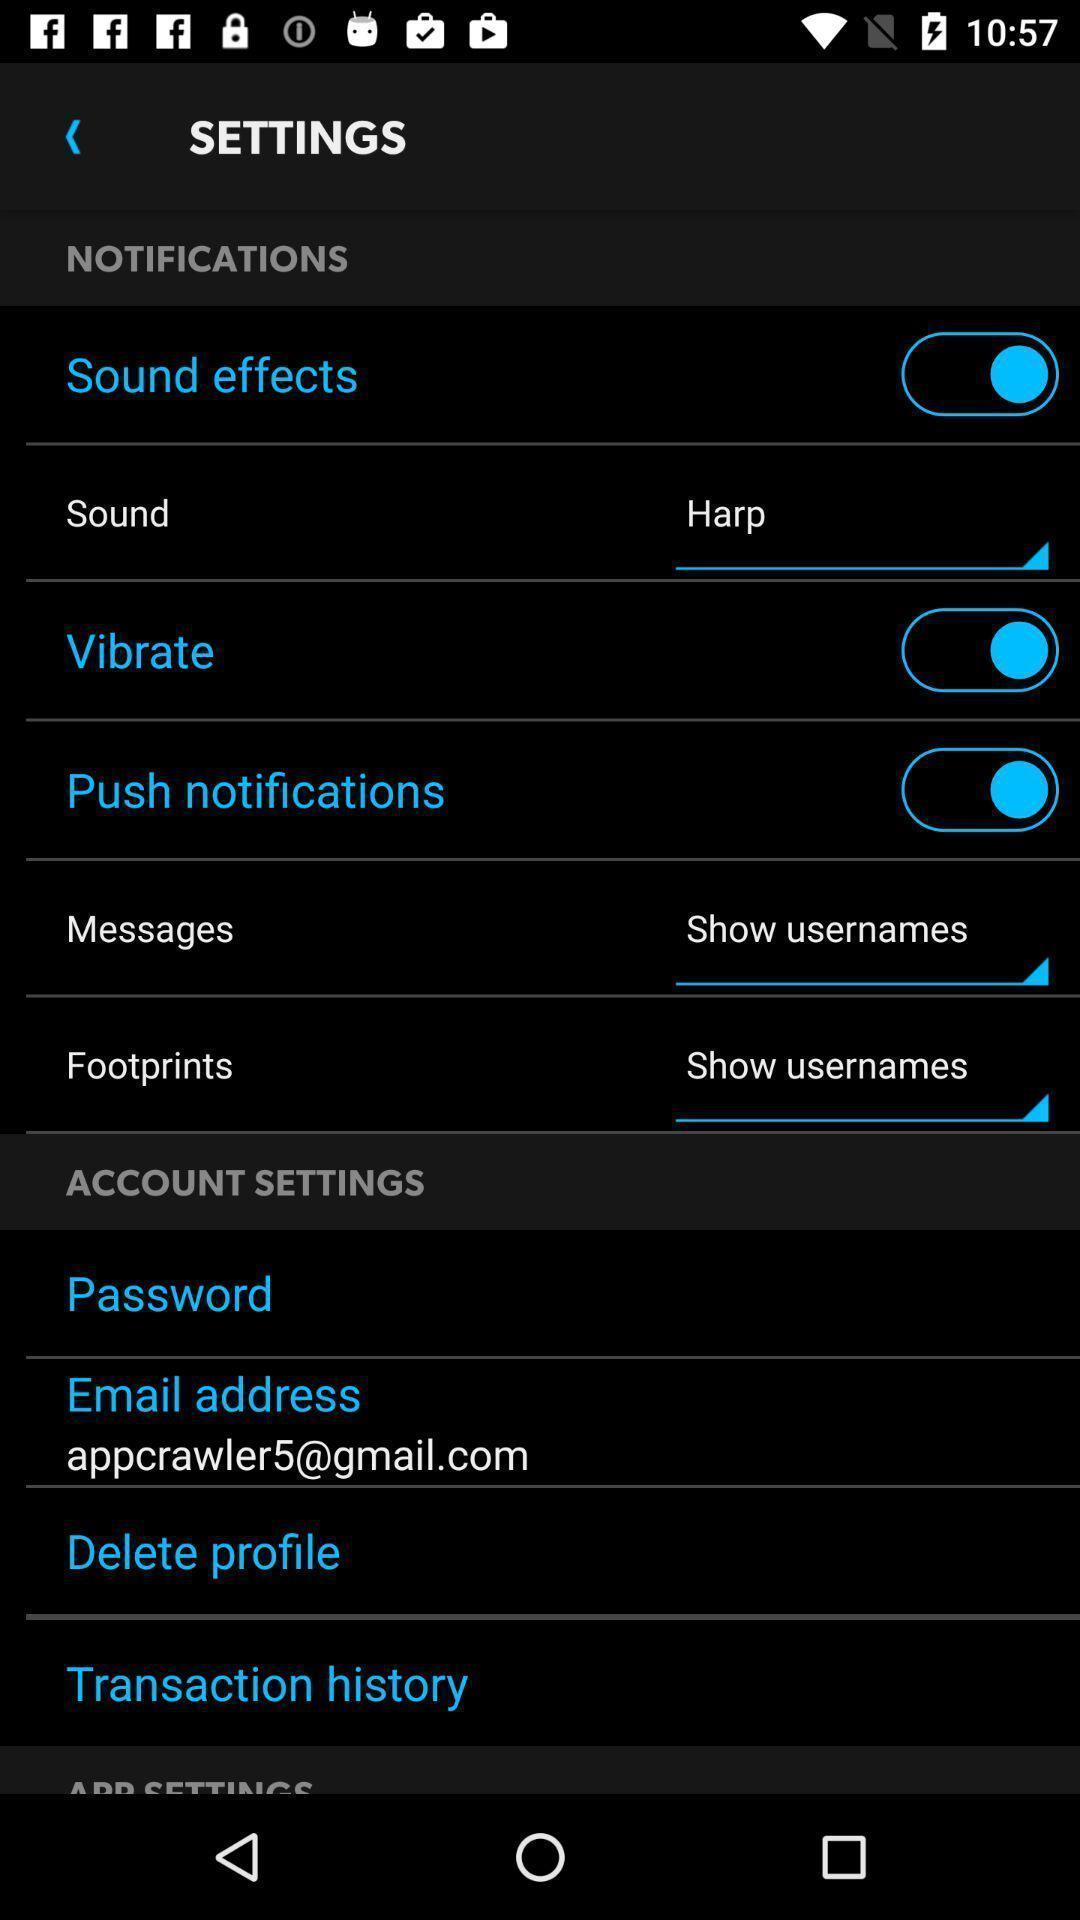Tell me about the visual elements in this screen capture. Page showing settings section. 